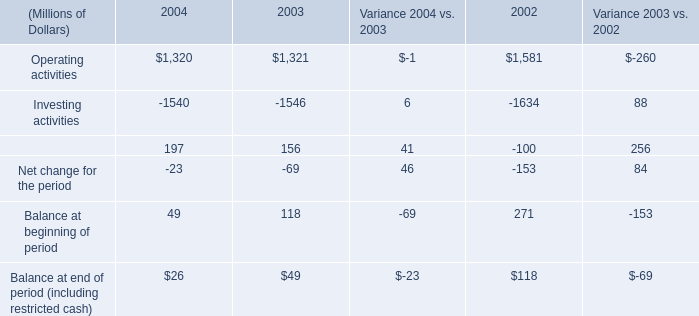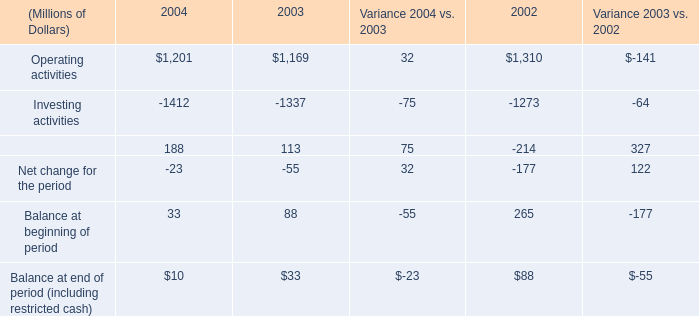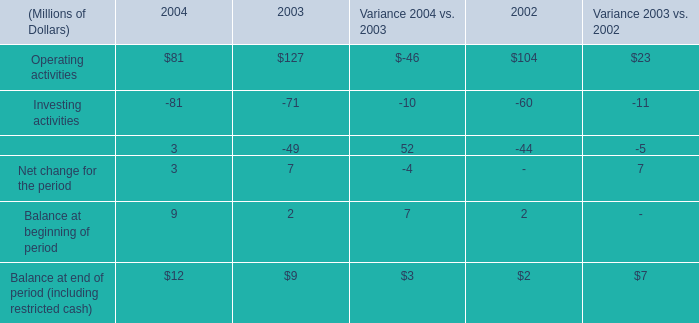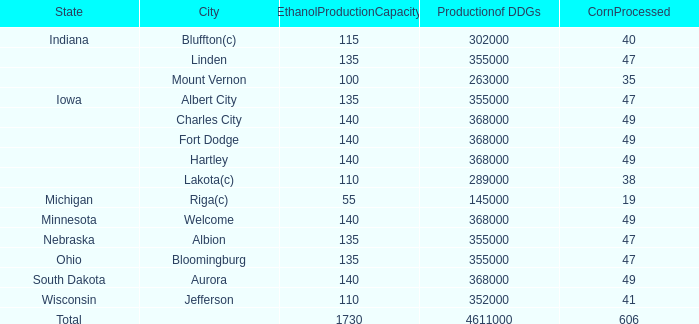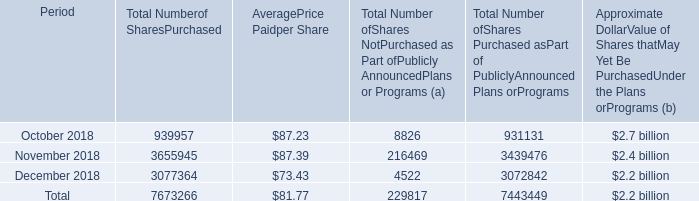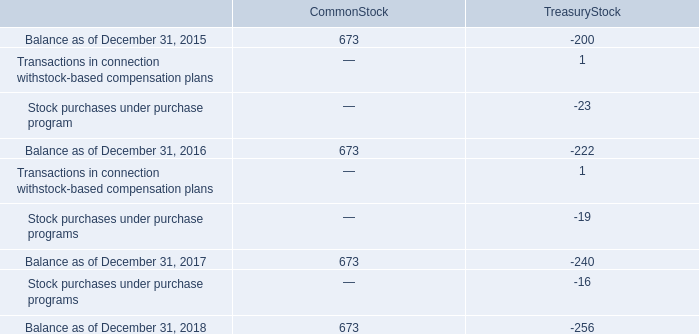how much , in billions , was spent purchasing common stock under the programs from 2016-2018? 
Computations: ((1.5 + 1.3) + 1.3)
Answer: 4.1. 